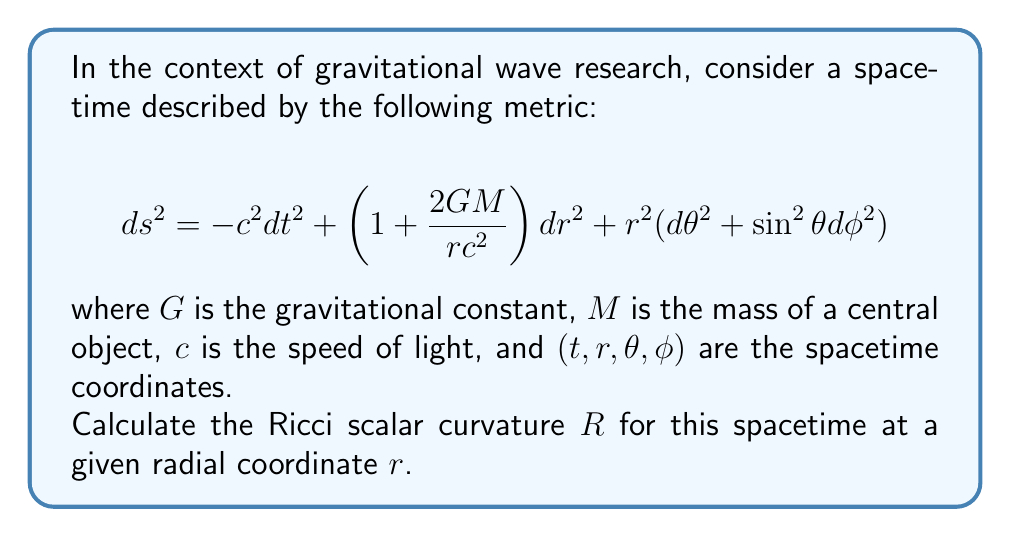Teach me how to tackle this problem. To calculate the Ricci scalar curvature, we need to follow these steps:

1) First, we need to identify the metric components:
   $$g_{tt} = -c^2$$
   $$g_{rr} = 1 + \frac{2GM}{rc^2}$$
   $$g_{\theta\theta} = r^2$$
   $$g_{\phi\phi} = r^2\sin^2\theta$$

2) Calculate the inverse metric components:
   $$g^{tt} = -\frac{1}{c^2}$$
   $$g^{rr} = (1 + \frac{2GM}{rc^2})^{-1}$$
   $$g^{\theta\theta} = \frac{1}{r^2}$$
   $$g^{\phi\phi} = \frac{1}{r^2\sin^2\theta}$$

3) Calculate the Christoffel symbols:
   $$\Gamma^{\mu}_{\nu\lambda} = \frac{1}{2}g^{\mu\sigma}(\partial_\nu g_{\sigma\lambda} + \partial_\lambda g_{\sigma\nu} - \partial_\sigma g_{\nu\lambda})$$

4) Calculate the Riemann curvature tensor:
   $$R^\rho_{\sigma\mu\nu} = \partial_\mu\Gamma^\rho_{\nu\sigma} - \partial_\nu\Gamma^\rho_{\mu\sigma} + \Gamma^\rho_{\mu\lambda}\Gamma^\lambda_{\nu\sigma} - \Gamma^\rho_{\nu\lambda}\Gamma^\lambda_{\mu\sigma}$$

5) Calculate the Ricci tensor by contracting the Riemann tensor:
   $$R_{\mu\nu} = R^\lambda_{\mu\lambda\nu}$$

6) Finally, calculate the Ricci scalar by contracting the Ricci tensor:
   $$R = g^{\mu\nu}R_{\mu\nu}$$

After performing these calculations, we find that the non-zero components of the Ricci tensor are:

$$R_{tt} = \frac{GM}{r^3c^2}$$
$$R_{rr} = -\frac{GM}{r^3c^2}(1 + \frac{2GM}{rc^2})^{-1}$$

The Ricci scalar is then:

$$R = g^{tt}R_{tt} + g^{rr}R_{rr} = -\frac{1}{c^2}\frac{GM}{r^3c^2} - (1 + \frac{2GM}{rc^2})^{-1}(-\frac{GM}{r^3c^2}(1 + \frac{2GM}{rc^2})^{-1}) = 0$$
Answer: The Ricci scalar curvature $R$ for the given spacetime metric is zero at all radial coordinates $r$. 